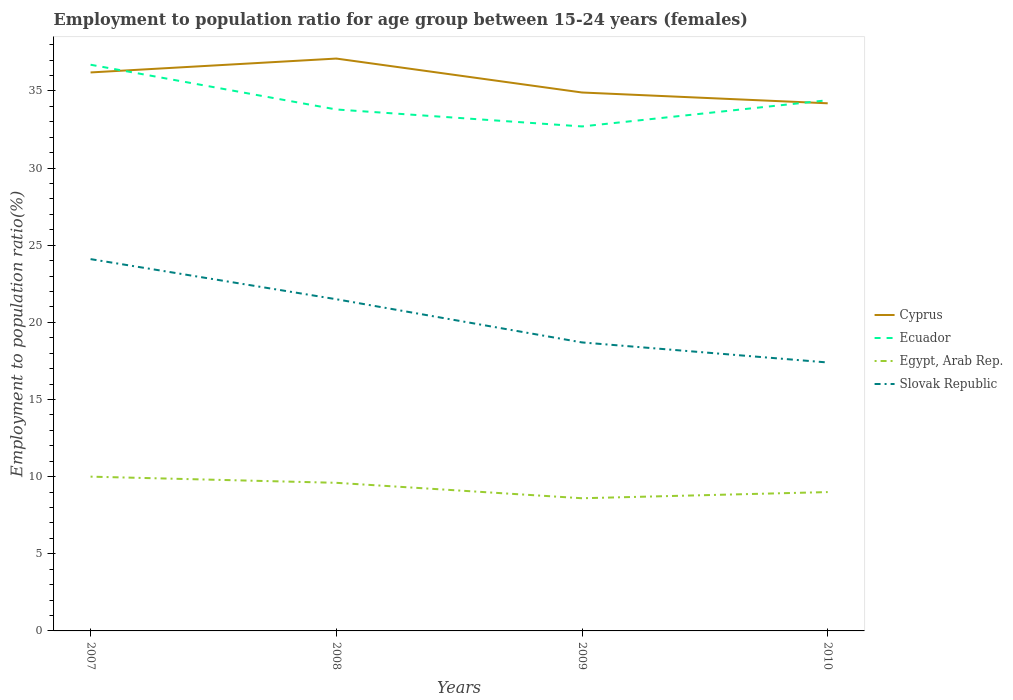How many different coloured lines are there?
Provide a short and direct response. 4. Across all years, what is the maximum employment to population ratio in Cyprus?
Keep it short and to the point. 34.2. In which year was the employment to population ratio in Ecuador maximum?
Keep it short and to the point. 2009. What is the total employment to population ratio in Egypt, Arab Rep. in the graph?
Make the answer very short. 0.6. What is the difference between the highest and the second highest employment to population ratio in Egypt, Arab Rep.?
Your response must be concise. 1.4. How many lines are there?
Give a very brief answer. 4. Are the values on the major ticks of Y-axis written in scientific E-notation?
Keep it short and to the point. No. How many legend labels are there?
Provide a succinct answer. 4. How are the legend labels stacked?
Keep it short and to the point. Vertical. What is the title of the graph?
Offer a very short reply. Employment to population ratio for age group between 15-24 years (females). What is the label or title of the X-axis?
Ensure brevity in your answer.  Years. What is the label or title of the Y-axis?
Make the answer very short. Employment to population ratio(%). What is the Employment to population ratio(%) in Cyprus in 2007?
Keep it short and to the point. 36.2. What is the Employment to population ratio(%) in Ecuador in 2007?
Your answer should be very brief. 36.7. What is the Employment to population ratio(%) of Egypt, Arab Rep. in 2007?
Your answer should be very brief. 10. What is the Employment to population ratio(%) of Slovak Republic in 2007?
Offer a very short reply. 24.1. What is the Employment to population ratio(%) in Cyprus in 2008?
Ensure brevity in your answer.  37.1. What is the Employment to population ratio(%) of Ecuador in 2008?
Your response must be concise. 33.8. What is the Employment to population ratio(%) of Egypt, Arab Rep. in 2008?
Make the answer very short. 9.6. What is the Employment to population ratio(%) in Cyprus in 2009?
Your answer should be compact. 34.9. What is the Employment to population ratio(%) in Ecuador in 2009?
Offer a terse response. 32.7. What is the Employment to population ratio(%) in Egypt, Arab Rep. in 2009?
Provide a short and direct response. 8.6. What is the Employment to population ratio(%) of Slovak Republic in 2009?
Provide a short and direct response. 18.7. What is the Employment to population ratio(%) of Cyprus in 2010?
Give a very brief answer. 34.2. What is the Employment to population ratio(%) in Ecuador in 2010?
Ensure brevity in your answer.  34.4. What is the Employment to population ratio(%) in Egypt, Arab Rep. in 2010?
Offer a terse response. 9. What is the Employment to population ratio(%) in Slovak Republic in 2010?
Ensure brevity in your answer.  17.4. Across all years, what is the maximum Employment to population ratio(%) in Cyprus?
Offer a terse response. 37.1. Across all years, what is the maximum Employment to population ratio(%) in Ecuador?
Provide a succinct answer. 36.7. Across all years, what is the maximum Employment to population ratio(%) in Egypt, Arab Rep.?
Offer a very short reply. 10. Across all years, what is the maximum Employment to population ratio(%) in Slovak Republic?
Keep it short and to the point. 24.1. Across all years, what is the minimum Employment to population ratio(%) in Cyprus?
Make the answer very short. 34.2. Across all years, what is the minimum Employment to population ratio(%) in Ecuador?
Offer a terse response. 32.7. Across all years, what is the minimum Employment to population ratio(%) in Egypt, Arab Rep.?
Keep it short and to the point. 8.6. Across all years, what is the minimum Employment to population ratio(%) of Slovak Republic?
Make the answer very short. 17.4. What is the total Employment to population ratio(%) of Cyprus in the graph?
Your response must be concise. 142.4. What is the total Employment to population ratio(%) in Ecuador in the graph?
Make the answer very short. 137.6. What is the total Employment to population ratio(%) in Egypt, Arab Rep. in the graph?
Offer a terse response. 37.2. What is the total Employment to population ratio(%) of Slovak Republic in the graph?
Your answer should be compact. 81.7. What is the difference between the Employment to population ratio(%) of Cyprus in 2007 and that in 2008?
Your answer should be compact. -0.9. What is the difference between the Employment to population ratio(%) of Ecuador in 2007 and that in 2008?
Keep it short and to the point. 2.9. What is the difference between the Employment to population ratio(%) in Egypt, Arab Rep. in 2007 and that in 2008?
Provide a short and direct response. 0.4. What is the difference between the Employment to population ratio(%) of Ecuador in 2007 and that in 2009?
Give a very brief answer. 4. What is the difference between the Employment to population ratio(%) in Egypt, Arab Rep. in 2007 and that in 2009?
Keep it short and to the point. 1.4. What is the difference between the Employment to population ratio(%) in Egypt, Arab Rep. in 2007 and that in 2010?
Your answer should be very brief. 1. What is the difference between the Employment to population ratio(%) in Slovak Republic in 2007 and that in 2010?
Offer a very short reply. 6.7. What is the difference between the Employment to population ratio(%) of Egypt, Arab Rep. in 2008 and that in 2009?
Your response must be concise. 1. What is the difference between the Employment to population ratio(%) in Slovak Republic in 2008 and that in 2009?
Provide a short and direct response. 2.8. What is the difference between the Employment to population ratio(%) in Ecuador in 2008 and that in 2010?
Your answer should be very brief. -0.6. What is the difference between the Employment to population ratio(%) in Cyprus in 2009 and that in 2010?
Give a very brief answer. 0.7. What is the difference between the Employment to population ratio(%) in Cyprus in 2007 and the Employment to population ratio(%) in Ecuador in 2008?
Your answer should be compact. 2.4. What is the difference between the Employment to population ratio(%) of Cyprus in 2007 and the Employment to population ratio(%) of Egypt, Arab Rep. in 2008?
Provide a succinct answer. 26.6. What is the difference between the Employment to population ratio(%) of Cyprus in 2007 and the Employment to population ratio(%) of Slovak Republic in 2008?
Make the answer very short. 14.7. What is the difference between the Employment to population ratio(%) of Ecuador in 2007 and the Employment to population ratio(%) of Egypt, Arab Rep. in 2008?
Provide a short and direct response. 27.1. What is the difference between the Employment to population ratio(%) in Ecuador in 2007 and the Employment to population ratio(%) in Slovak Republic in 2008?
Offer a very short reply. 15.2. What is the difference between the Employment to population ratio(%) of Egypt, Arab Rep. in 2007 and the Employment to population ratio(%) of Slovak Republic in 2008?
Provide a short and direct response. -11.5. What is the difference between the Employment to population ratio(%) of Cyprus in 2007 and the Employment to population ratio(%) of Egypt, Arab Rep. in 2009?
Offer a terse response. 27.6. What is the difference between the Employment to population ratio(%) of Cyprus in 2007 and the Employment to population ratio(%) of Slovak Republic in 2009?
Keep it short and to the point. 17.5. What is the difference between the Employment to population ratio(%) of Ecuador in 2007 and the Employment to population ratio(%) of Egypt, Arab Rep. in 2009?
Your answer should be compact. 28.1. What is the difference between the Employment to population ratio(%) in Ecuador in 2007 and the Employment to population ratio(%) in Slovak Republic in 2009?
Provide a succinct answer. 18. What is the difference between the Employment to population ratio(%) in Egypt, Arab Rep. in 2007 and the Employment to population ratio(%) in Slovak Republic in 2009?
Your answer should be compact. -8.7. What is the difference between the Employment to population ratio(%) of Cyprus in 2007 and the Employment to population ratio(%) of Egypt, Arab Rep. in 2010?
Ensure brevity in your answer.  27.2. What is the difference between the Employment to population ratio(%) of Cyprus in 2007 and the Employment to population ratio(%) of Slovak Republic in 2010?
Make the answer very short. 18.8. What is the difference between the Employment to population ratio(%) of Ecuador in 2007 and the Employment to population ratio(%) of Egypt, Arab Rep. in 2010?
Ensure brevity in your answer.  27.7. What is the difference between the Employment to population ratio(%) in Ecuador in 2007 and the Employment to population ratio(%) in Slovak Republic in 2010?
Your response must be concise. 19.3. What is the difference between the Employment to population ratio(%) in Cyprus in 2008 and the Employment to population ratio(%) in Ecuador in 2009?
Give a very brief answer. 4.4. What is the difference between the Employment to population ratio(%) of Cyprus in 2008 and the Employment to population ratio(%) of Egypt, Arab Rep. in 2009?
Your answer should be very brief. 28.5. What is the difference between the Employment to population ratio(%) in Ecuador in 2008 and the Employment to population ratio(%) in Egypt, Arab Rep. in 2009?
Keep it short and to the point. 25.2. What is the difference between the Employment to population ratio(%) in Ecuador in 2008 and the Employment to population ratio(%) in Slovak Republic in 2009?
Your response must be concise. 15.1. What is the difference between the Employment to population ratio(%) in Egypt, Arab Rep. in 2008 and the Employment to population ratio(%) in Slovak Republic in 2009?
Offer a very short reply. -9.1. What is the difference between the Employment to population ratio(%) of Cyprus in 2008 and the Employment to population ratio(%) of Egypt, Arab Rep. in 2010?
Give a very brief answer. 28.1. What is the difference between the Employment to population ratio(%) in Ecuador in 2008 and the Employment to population ratio(%) in Egypt, Arab Rep. in 2010?
Make the answer very short. 24.8. What is the difference between the Employment to population ratio(%) in Ecuador in 2008 and the Employment to population ratio(%) in Slovak Republic in 2010?
Ensure brevity in your answer.  16.4. What is the difference between the Employment to population ratio(%) in Cyprus in 2009 and the Employment to population ratio(%) in Egypt, Arab Rep. in 2010?
Ensure brevity in your answer.  25.9. What is the difference between the Employment to population ratio(%) of Cyprus in 2009 and the Employment to population ratio(%) of Slovak Republic in 2010?
Provide a short and direct response. 17.5. What is the difference between the Employment to population ratio(%) of Ecuador in 2009 and the Employment to population ratio(%) of Egypt, Arab Rep. in 2010?
Offer a very short reply. 23.7. What is the difference between the Employment to population ratio(%) in Ecuador in 2009 and the Employment to population ratio(%) in Slovak Republic in 2010?
Provide a succinct answer. 15.3. What is the average Employment to population ratio(%) of Cyprus per year?
Offer a terse response. 35.6. What is the average Employment to population ratio(%) of Ecuador per year?
Provide a short and direct response. 34.4. What is the average Employment to population ratio(%) in Egypt, Arab Rep. per year?
Offer a terse response. 9.3. What is the average Employment to population ratio(%) of Slovak Republic per year?
Offer a very short reply. 20.43. In the year 2007, what is the difference between the Employment to population ratio(%) of Cyprus and Employment to population ratio(%) of Ecuador?
Offer a very short reply. -0.5. In the year 2007, what is the difference between the Employment to population ratio(%) of Cyprus and Employment to population ratio(%) of Egypt, Arab Rep.?
Offer a very short reply. 26.2. In the year 2007, what is the difference between the Employment to population ratio(%) of Ecuador and Employment to population ratio(%) of Egypt, Arab Rep.?
Make the answer very short. 26.7. In the year 2007, what is the difference between the Employment to population ratio(%) of Egypt, Arab Rep. and Employment to population ratio(%) of Slovak Republic?
Keep it short and to the point. -14.1. In the year 2008, what is the difference between the Employment to population ratio(%) of Cyprus and Employment to population ratio(%) of Egypt, Arab Rep.?
Provide a short and direct response. 27.5. In the year 2008, what is the difference between the Employment to population ratio(%) of Ecuador and Employment to population ratio(%) of Egypt, Arab Rep.?
Offer a very short reply. 24.2. In the year 2008, what is the difference between the Employment to population ratio(%) in Egypt, Arab Rep. and Employment to population ratio(%) in Slovak Republic?
Keep it short and to the point. -11.9. In the year 2009, what is the difference between the Employment to population ratio(%) in Cyprus and Employment to population ratio(%) in Ecuador?
Your response must be concise. 2.2. In the year 2009, what is the difference between the Employment to population ratio(%) in Cyprus and Employment to population ratio(%) in Egypt, Arab Rep.?
Provide a short and direct response. 26.3. In the year 2009, what is the difference between the Employment to population ratio(%) of Cyprus and Employment to population ratio(%) of Slovak Republic?
Provide a short and direct response. 16.2. In the year 2009, what is the difference between the Employment to population ratio(%) in Ecuador and Employment to population ratio(%) in Egypt, Arab Rep.?
Ensure brevity in your answer.  24.1. In the year 2009, what is the difference between the Employment to population ratio(%) of Ecuador and Employment to population ratio(%) of Slovak Republic?
Provide a succinct answer. 14. In the year 2009, what is the difference between the Employment to population ratio(%) of Egypt, Arab Rep. and Employment to population ratio(%) of Slovak Republic?
Offer a very short reply. -10.1. In the year 2010, what is the difference between the Employment to population ratio(%) in Cyprus and Employment to population ratio(%) in Ecuador?
Provide a short and direct response. -0.2. In the year 2010, what is the difference between the Employment to population ratio(%) in Cyprus and Employment to population ratio(%) in Egypt, Arab Rep.?
Give a very brief answer. 25.2. In the year 2010, what is the difference between the Employment to population ratio(%) in Cyprus and Employment to population ratio(%) in Slovak Republic?
Your answer should be compact. 16.8. In the year 2010, what is the difference between the Employment to population ratio(%) in Ecuador and Employment to population ratio(%) in Egypt, Arab Rep.?
Offer a terse response. 25.4. In the year 2010, what is the difference between the Employment to population ratio(%) in Ecuador and Employment to population ratio(%) in Slovak Republic?
Provide a short and direct response. 17. What is the ratio of the Employment to population ratio(%) of Cyprus in 2007 to that in 2008?
Your answer should be compact. 0.98. What is the ratio of the Employment to population ratio(%) of Ecuador in 2007 to that in 2008?
Make the answer very short. 1.09. What is the ratio of the Employment to population ratio(%) in Egypt, Arab Rep. in 2007 to that in 2008?
Make the answer very short. 1.04. What is the ratio of the Employment to population ratio(%) in Slovak Republic in 2007 to that in 2008?
Provide a succinct answer. 1.12. What is the ratio of the Employment to population ratio(%) in Cyprus in 2007 to that in 2009?
Provide a short and direct response. 1.04. What is the ratio of the Employment to population ratio(%) of Ecuador in 2007 to that in 2009?
Give a very brief answer. 1.12. What is the ratio of the Employment to population ratio(%) in Egypt, Arab Rep. in 2007 to that in 2009?
Your response must be concise. 1.16. What is the ratio of the Employment to population ratio(%) in Slovak Republic in 2007 to that in 2009?
Give a very brief answer. 1.29. What is the ratio of the Employment to population ratio(%) of Cyprus in 2007 to that in 2010?
Offer a terse response. 1.06. What is the ratio of the Employment to population ratio(%) in Ecuador in 2007 to that in 2010?
Offer a terse response. 1.07. What is the ratio of the Employment to population ratio(%) in Slovak Republic in 2007 to that in 2010?
Your answer should be very brief. 1.39. What is the ratio of the Employment to population ratio(%) in Cyprus in 2008 to that in 2009?
Provide a succinct answer. 1.06. What is the ratio of the Employment to population ratio(%) of Ecuador in 2008 to that in 2009?
Your response must be concise. 1.03. What is the ratio of the Employment to population ratio(%) of Egypt, Arab Rep. in 2008 to that in 2009?
Your answer should be compact. 1.12. What is the ratio of the Employment to population ratio(%) in Slovak Republic in 2008 to that in 2009?
Your answer should be compact. 1.15. What is the ratio of the Employment to population ratio(%) in Cyprus in 2008 to that in 2010?
Offer a very short reply. 1.08. What is the ratio of the Employment to population ratio(%) in Ecuador in 2008 to that in 2010?
Offer a very short reply. 0.98. What is the ratio of the Employment to population ratio(%) of Egypt, Arab Rep. in 2008 to that in 2010?
Your answer should be very brief. 1.07. What is the ratio of the Employment to population ratio(%) of Slovak Republic in 2008 to that in 2010?
Your response must be concise. 1.24. What is the ratio of the Employment to population ratio(%) in Cyprus in 2009 to that in 2010?
Offer a terse response. 1.02. What is the ratio of the Employment to population ratio(%) in Ecuador in 2009 to that in 2010?
Offer a very short reply. 0.95. What is the ratio of the Employment to population ratio(%) in Egypt, Arab Rep. in 2009 to that in 2010?
Provide a short and direct response. 0.96. What is the ratio of the Employment to population ratio(%) in Slovak Republic in 2009 to that in 2010?
Ensure brevity in your answer.  1.07. What is the difference between the highest and the second highest Employment to population ratio(%) in Ecuador?
Give a very brief answer. 2.3. What is the difference between the highest and the lowest Employment to population ratio(%) in Cyprus?
Keep it short and to the point. 2.9. What is the difference between the highest and the lowest Employment to population ratio(%) in Ecuador?
Provide a short and direct response. 4. What is the difference between the highest and the lowest Employment to population ratio(%) of Egypt, Arab Rep.?
Keep it short and to the point. 1.4. What is the difference between the highest and the lowest Employment to population ratio(%) of Slovak Republic?
Provide a succinct answer. 6.7. 